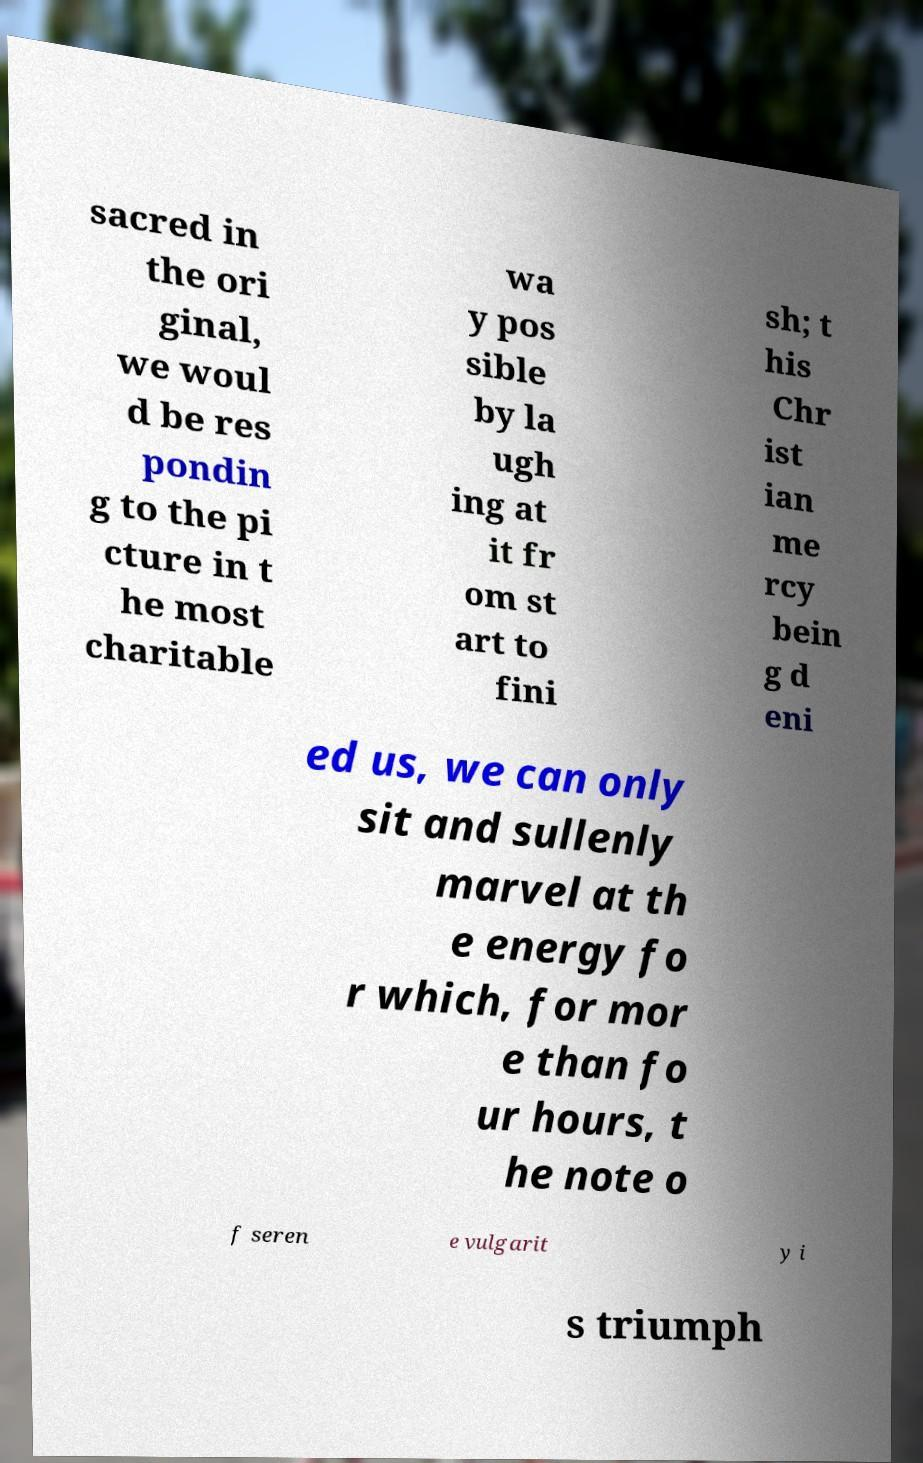What messages or text are displayed in this image? I need them in a readable, typed format. sacred in the ori ginal, we woul d be res pondin g to the pi cture in t he most charitable wa y pos sible by la ugh ing at it fr om st art to fini sh; t his Chr ist ian me rcy bein g d eni ed us, we can only sit and sullenly marvel at th e energy fo r which, for mor e than fo ur hours, t he note o f seren e vulgarit y i s triumph 